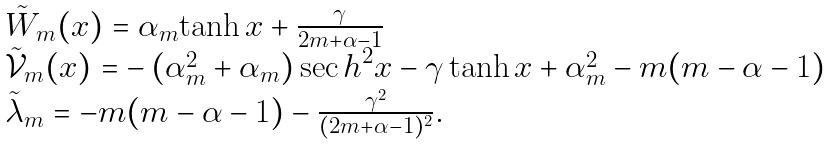<formula> <loc_0><loc_0><loc_500><loc_500>\begin{array} { l } \tilde { W } _ { m } ( x ) = \alpha _ { m } { \tanh } \, x + \frac { \gamma } { 2 m + \alpha - 1 } \\ \tilde { \mathcal { V } } _ { m } ( x ) = - \left ( \alpha _ { m } ^ { 2 } + \alpha _ { m } \right ) { \sec h } ^ { 2 } x - \gamma \, { \tanh } \, x + \alpha _ { m } ^ { 2 } - m ( m - \alpha - 1 ) \\ \tilde { \lambda } _ { m } = - m ( m - \alpha - 1 ) - \frac { { \gamma } ^ { 2 } } { ( 2 m + \alpha - 1 ) ^ { 2 } } . \end{array}</formula> 